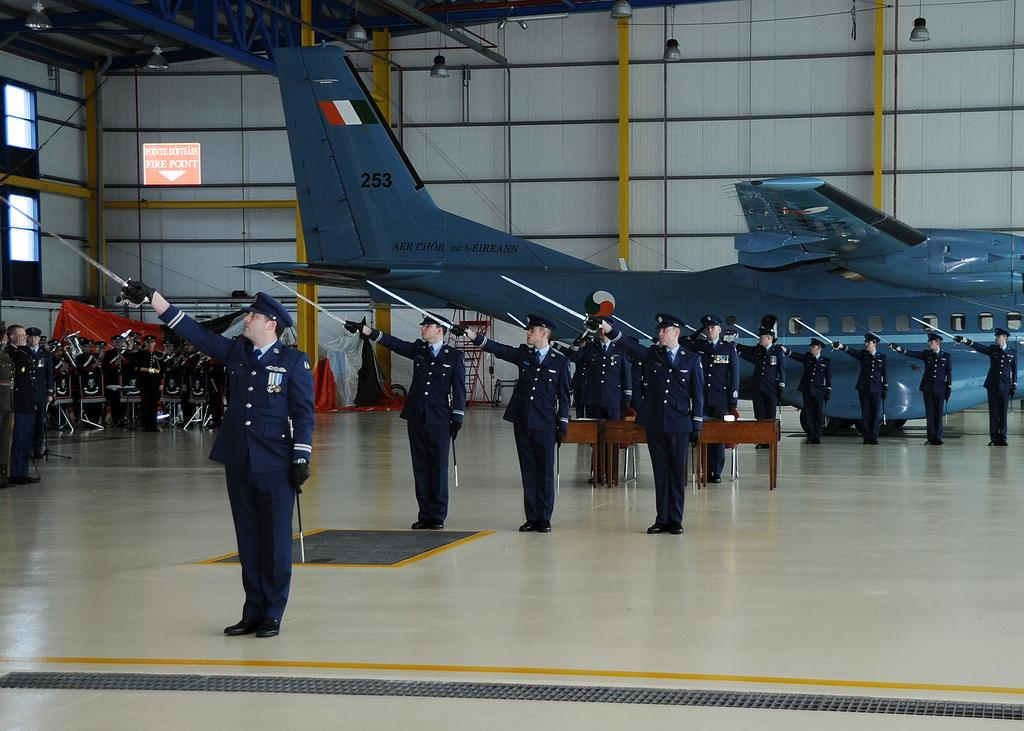<image>
Summarize the visual content of the image. A military ceremony is taking place in front of a plane with 253 painted on its tail. 